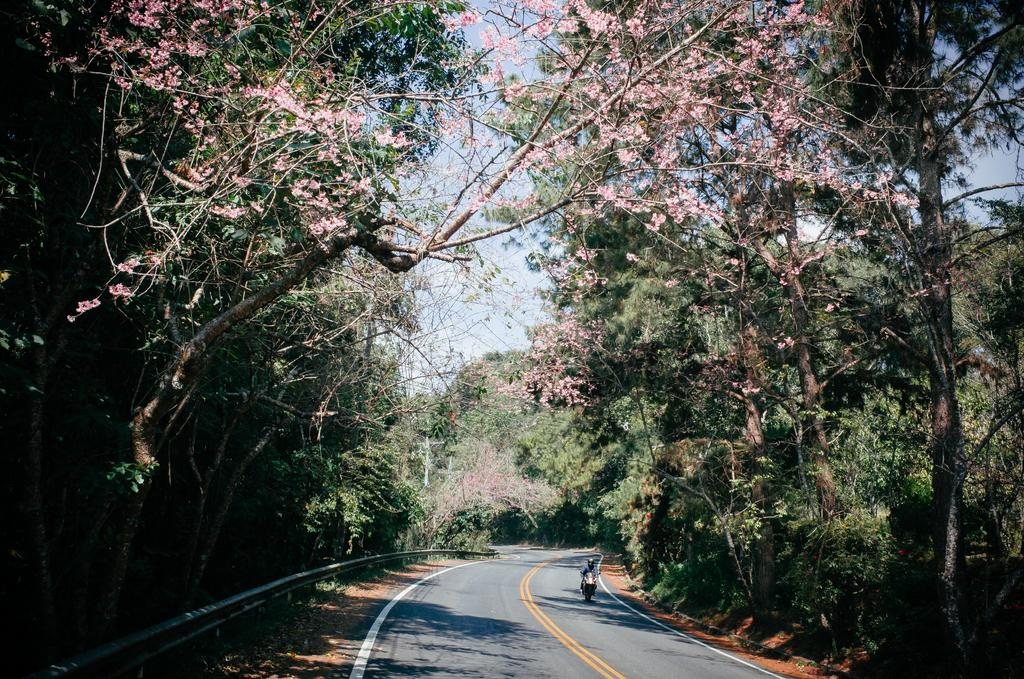What is the main subject of the image? There is a person riding a bike in the image. Where is the person riding the bike? The person is on the road. What can be seen in the background of the image? Trees and the sky are visible in the background of the image. What type of trousers is the person wearing while riding the bike in the image? There is no information about the person's trousers in the image, so it cannot be determined from the image. 